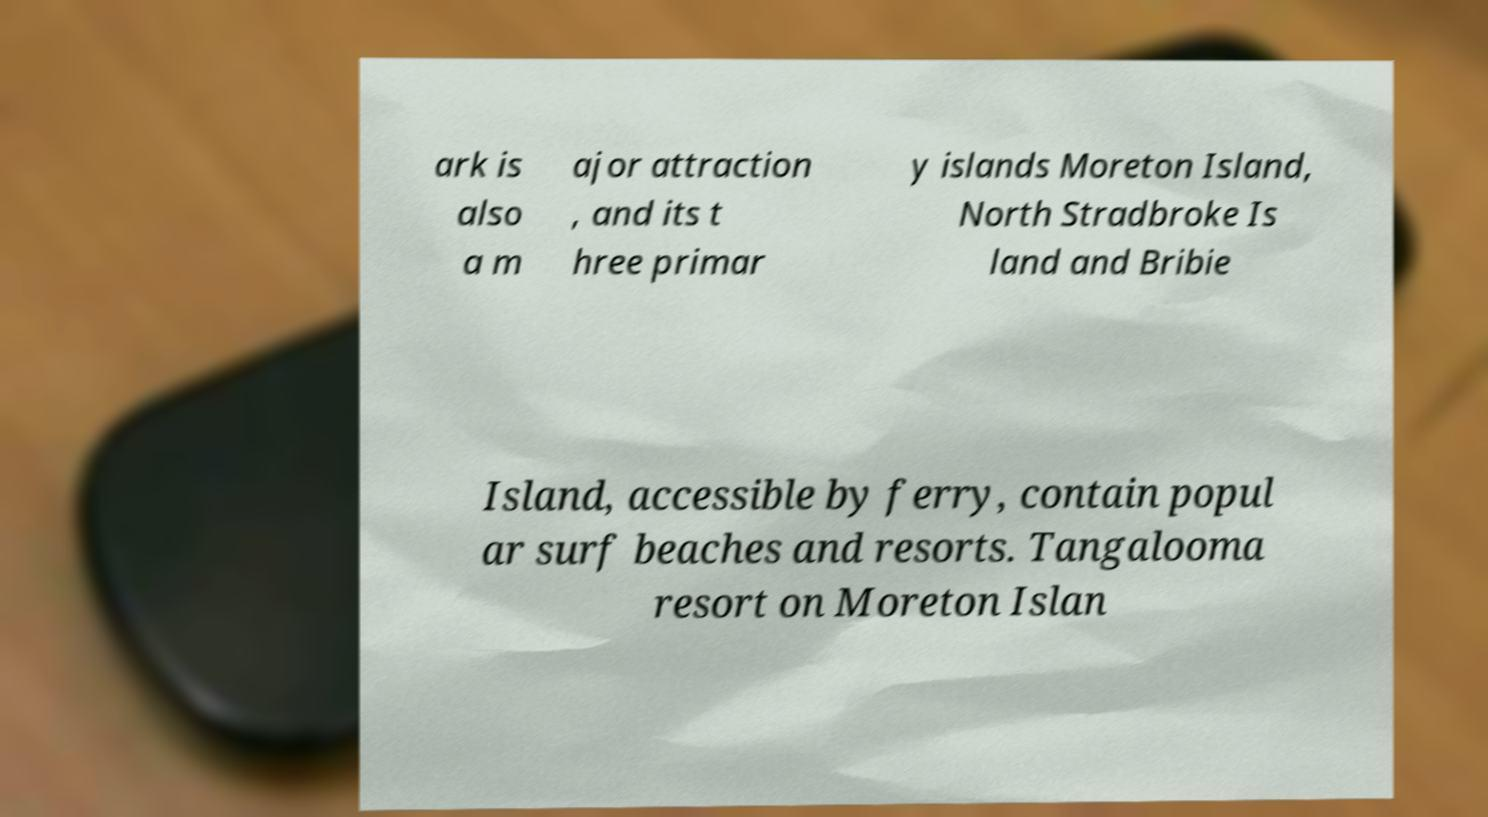For documentation purposes, I need the text within this image transcribed. Could you provide that? ark is also a m ajor attraction , and its t hree primar y islands Moreton Island, North Stradbroke Is land and Bribie Island, accessible by ferry, contain popul ar surf beaches and resorts. Tangalooma resort on Moreton Islan 